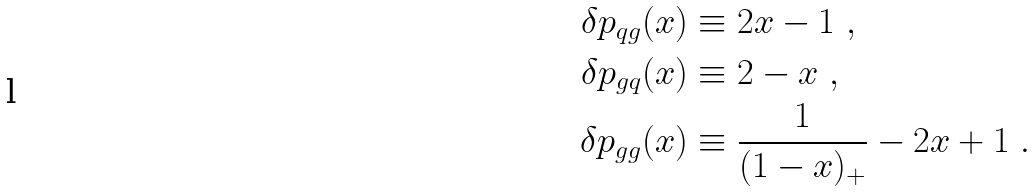<formula> <loc_0><loc_0><loc_500><loc_500>\delta p _ { q g } ( x ) & \equiv 2 x - 1 \ , \\ \delta p _ { g q } ( x ) & \equiv 2 - x \ , \\ \delta p _ { g g } ( x ) & \equiv \frac { 1 } { ( 1 - x ) _ { + } } - 2 x + 1 \ .</formula> 